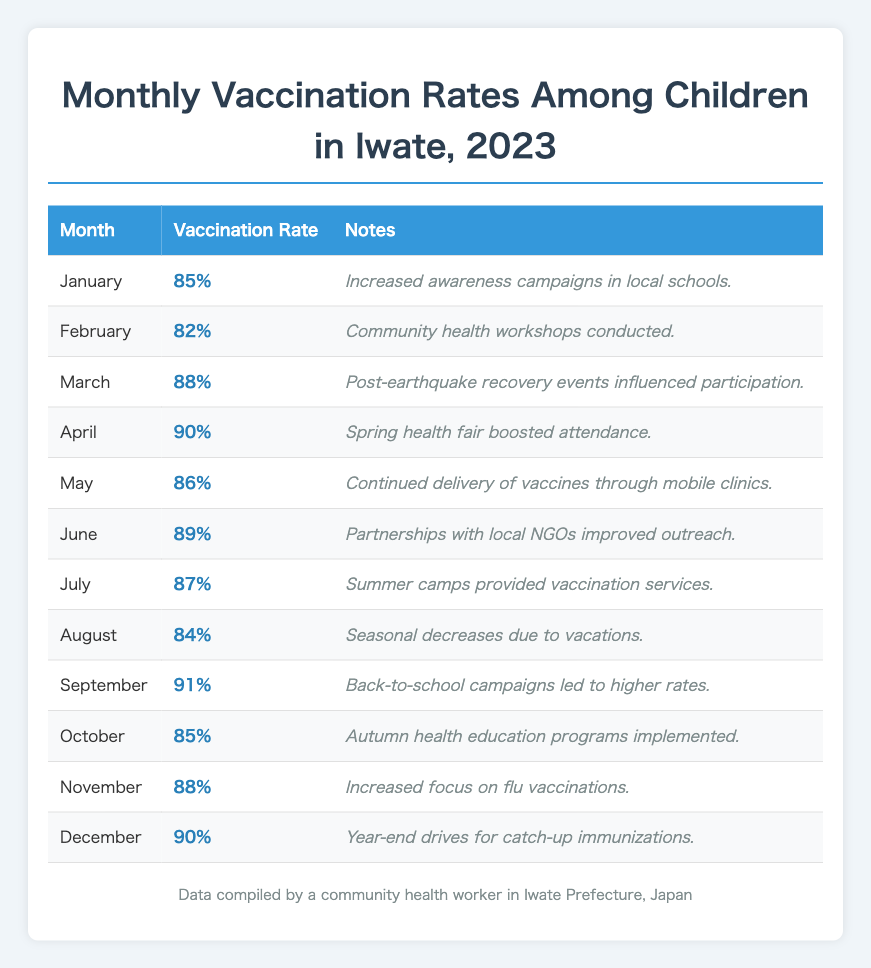What was the vaccination rate in March? The table shows that the vaccination rate in March is listed as 88%.
Answer: 88% What was the highest vaccination rate recorded in 2023? By reviewing the vaccination rates, April has the highest rate at 90%.
Answer: 90% What were the vaccination rates for August and December? The table provides the vaccination rate for August as 84% and for December as 90%.
Answer: August: 84%, December: 90% Is it true that the vaccination rate in February was higher than in January? In the table, February's vaccination rate is 82%, while January's is 85%. Therefore, this statement is false.
Answer: No What is the average vaccination rate for the first half of the year (January to June)? To find the average, sum the rates for January (85%), February (82%), March (88%), April (90%), May (86%), and June (89%). Adding these gives 510%. Dividing by 6 yields an average of 85%.
Answer: 85% How did the vaccination rate change from July to September? The vaccination rate in July is 87% and in September is 91%. The change can be calculated as 91% - 87% = 4%, indicating an increase.
Answer: Increased by 4% Was there any month where the vaccination rate dropped below 85%? The table shows that February and August both had vaccination rates below 85%, at 82% and 84% respectively, confirming the statement is true.
Answer: Yes Which month had the most significant increase in vaccination rates compared to the previous month? Comparing the rates, September (91%) compared to August (84%) shows the largest increase of 7%.
Answer: September: 7% increase List the months where the vaccination rates were above 88%. The months with vaccination rates above 88% are March (88%), April (90%), June (89%), September (91%), November (88%), and December (90%).
Answer: March, April, June, September, November, December What impact did the spring health fair in April have on the vaccination rate compared to March? In March, the vaccination rate was 88%, and in April, it rose to 90%. This indicates an increase of 2%, suggesting the health fair had a positive impact.
Answer: Increased by 2% 